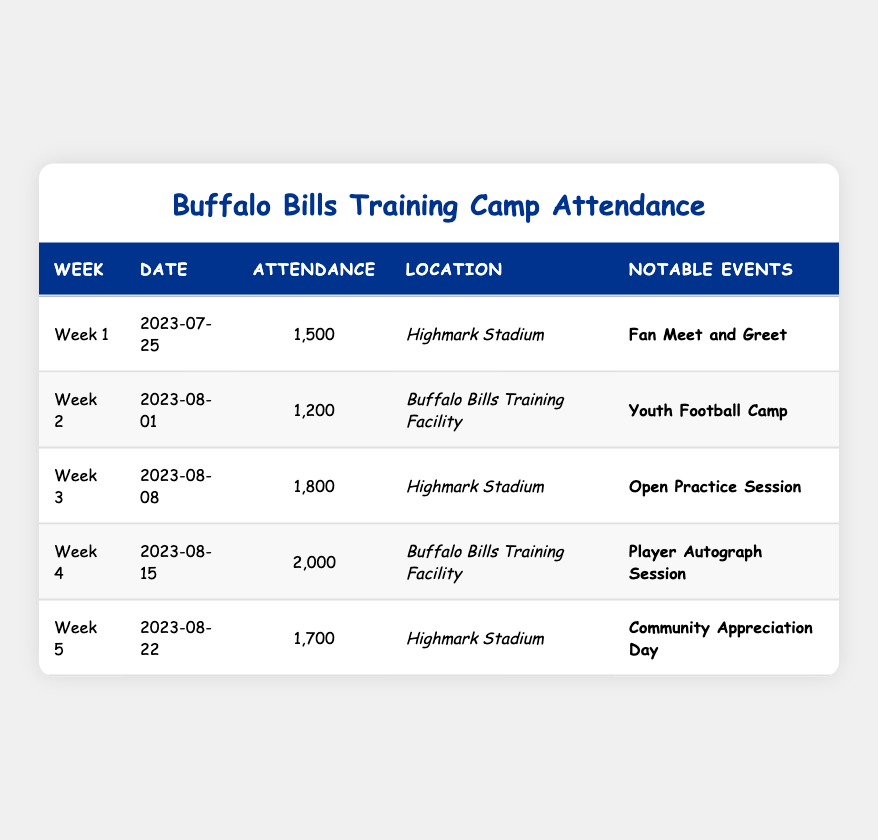What was the highest attendance recorded during the training camp? The attendance figures for each week are listed. The highest value among them is observed in Week 4, which recorded 2,000 attendees.
Answer: 2,000 Which location had the lowest attendance? By comparing the attendance numbers for each week, Week 2 at the Buffalo Bills Training Facility had the lowest attendance with 1,200.
Answer: Buffalo Bills Training Facility How many attendees were there in total over the 5 weeks? The total attendance is the sum of all weekly attendances: (1500 + 1200 + 1800 + 2000 + 1700) = 10,200.
Answer: 10,200 Did Week 3 have more attendees than Week 1? Week 3 had an attendance of 1,800, while Week 1 had 1,500. Since 1,800 is greater than 1,500, the statement is true.
Answer: Yes What is the average attendance during the training camp? The average can be calculated by dividing the total attendance (10,200) by the number of weeks (5): 10,200 / 5 = 2,040.
Answer: 2,040 How many notable events took place at the Highmark Stadium? Highmark Stadium hosted events during Weeks 1, 3, and 5. Therefore, there were 3 notable events at this location.
Answer: 3 Was there a notable event focusing on youth during the training camp? A youth football camp took place in Week 2, making the statement true.
Answer: Yes Which week had the highest attendance? Week 4 had the highest attendance with 2,000 attendees, the highest figure when compared to all other weeks.
Answer: Week 4 If we exclude Week 2, what is the average attendance for the remaining weeks? Excluding Week 2 means we sum attendances of Weeks 1, 3, 4, and 5: (1500 + 1800 + 2000 + 1700) = 7,000. The average attendance for these 4 weeks is 7,000 / 4 = 1,750.
Answer: 1,750 Which week featured a player autograph session? The notable event of a player autograph session occurred in Week 4, identifiable from the notable events column.
Answer: Week 4 